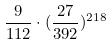<formula> <loc_0><loc_0><loc_500><loc_500>\frac { 9 } { 1 1 2 } \cdot ( \frac { 2 7 } { 3 9 2 } ) ^ { 2 1 8 }</formula> 